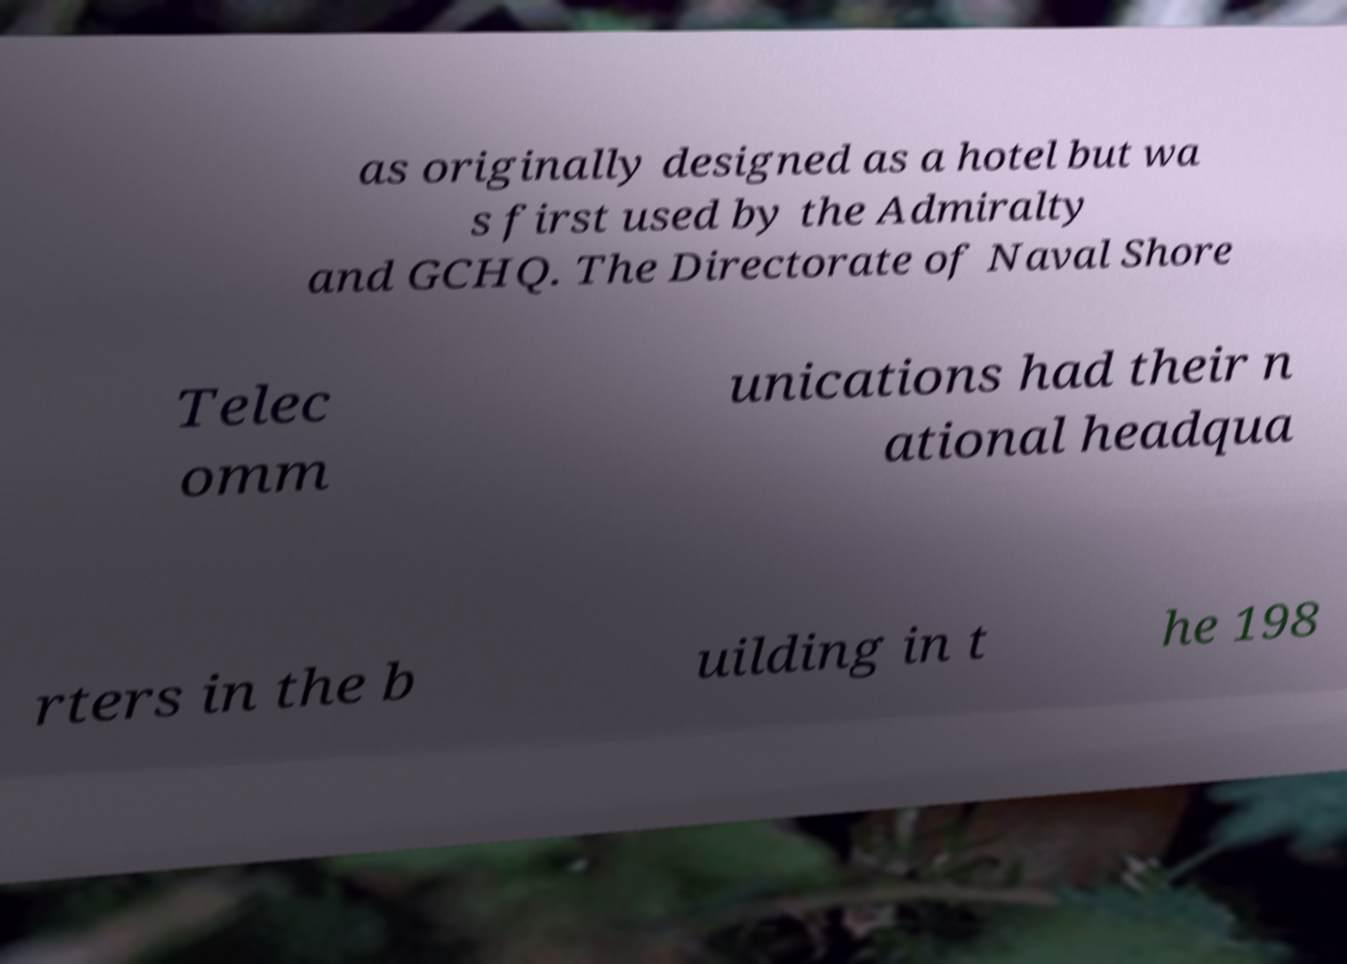Can you read and provide the text displayed in the image?This photo seems to have some interesting text. Can you extract and type it out for me? as originally designed as a hotel but wa s first used by the Admiralty and GCHQ. The Directorate of Naval Shore Telec omm unications had their n ational headqua rters in the b uilding in t he 198 